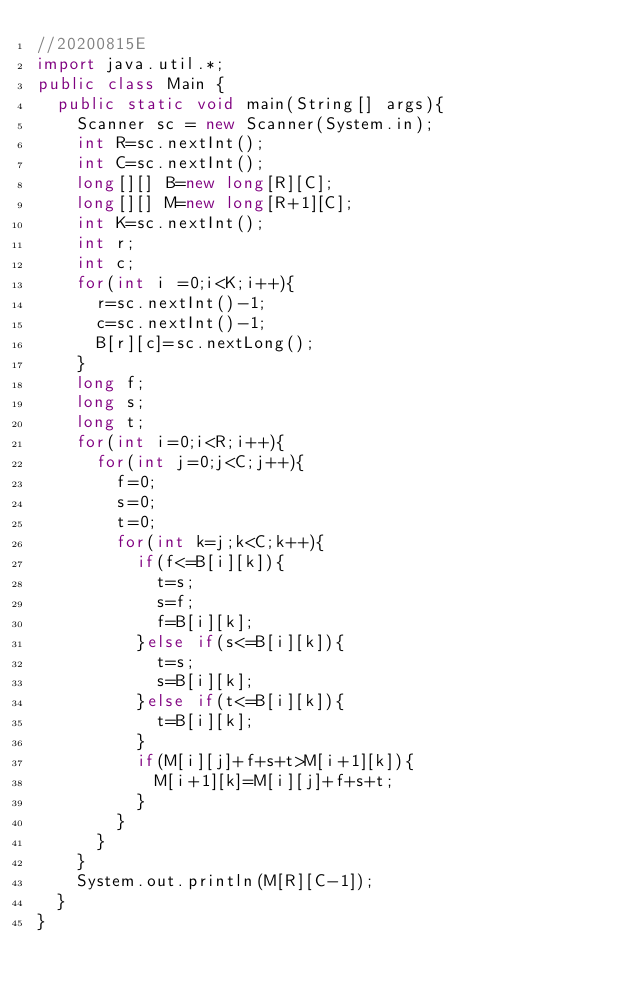<code> <loc_0><loc_0><loc_500><loc_500><_Java_>//20200815E
import java.util.*;
public class Main {
	public static void main(String[] args){
		Scanner sc = new Scanner(System.in);
		int R=sc.nextInt();
		int C=sc.nextInt();
		long[][] B=new long[R][C];
		long[][] M=new long[R+1][C];
		int K=sc.nextInt();
		int r;
		int c;
		for(int i =0;i<K;i++){
			r=sc.nextInt()-1;
			c=sc.nextInt()-1;
			B[r][c]=sc.nextLong();
		}
		long f;
		long s;
		long t;
		for(int i=0;i<R;i++){
			for(int j=0;j<C;j++){
				f=0;
				s=0;
				t=0;
				for(int k=j;k<C;k++){
					if(f<=B[i][k]){
						t=s;
						s=f;
						f=B[i][k];
					}else if(s<=B[i][k]){
						t=s;
						s=B[i][k];
					}else if(t<=B[i][k]){
						t=B[i][k];
					}
					if(M[i][j]+f+s+t>M[i+1][k]){
						M[i+1][k]=M[i][j]+f+s+t;
					}
				}
			}
		}
		System.out.println(M[R][C-1]);
	}
}
</code> 